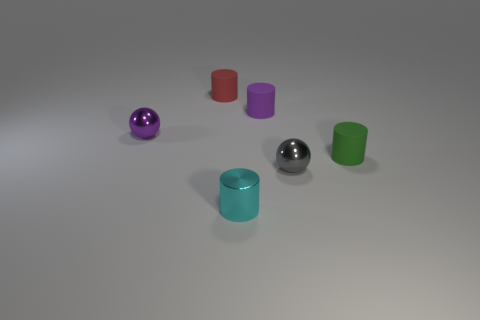The objects are arranged on what looks like a flat surface. Can you describe the texture and color of the surface? The surface appears to have a smooth texture with a soft, uniform grey tone. It reflects the objects slightly, hinting at a matte finish with just a hint of glossiness. 